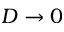Convert formula to latex. <formula><loc_0><loc_0><loc_500><loc_500>D \to 0</formula> 